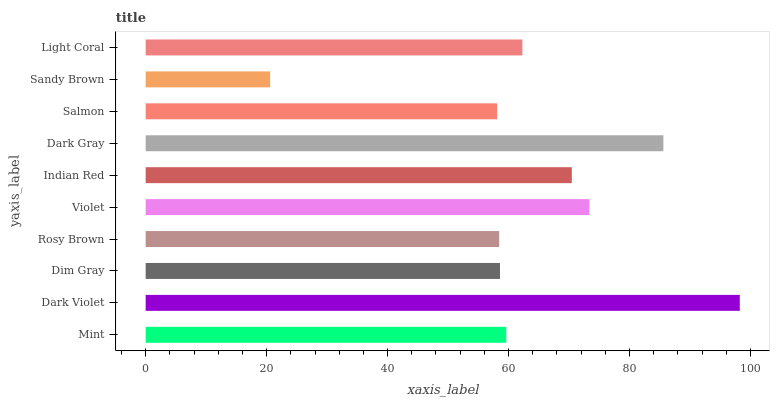Is Sandy Brown the minimum?
Answer yes or no. Yes. Is Dark Violet the maximum?
Answer yes or no. Yes. Is Dim Gray the minimum?
Answer yes or no. No. Is Dim Gray the maximum?
Answer yes or no. No. Is Dark Violet greater than Dim Gray?
Answer yes or no. Yes. Is Dim Gray less than Dark Violet?
Answer yes or no. Yes. Is Dim Gray greater than Dark Violet?
Answer yes or no. No. Is Dark Violet less than Dim Gray?
Answer yes or no. No. Is Light Coral the high median?
Answer yes or no. Yes. Is Mint the low median?
Answer yes or no. Yes. Is Sandy Brown the high median?
Answer yes or no. No. Is Salmon the low median?
Answer yes or no. No. 